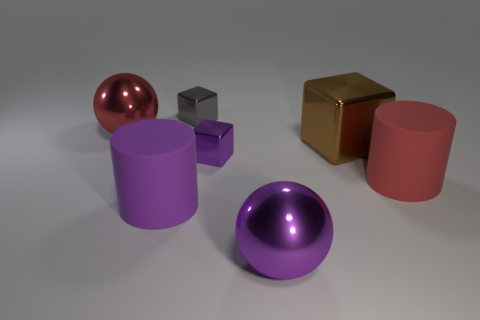Add 1 big purple balls. How many objects exist? 8 Subtract all cubes. How many objects are left? 4 Add 3 big brown blocks. How many big brown blocks exist? 4 Subtract 0 brown cylinders. How many objects are left? 7 Subtract all large red cylinders. Subtract all small blue rubber cylinders. How many objects are left? 6 Add 6 big red objects. How many big red objects are left? 8 